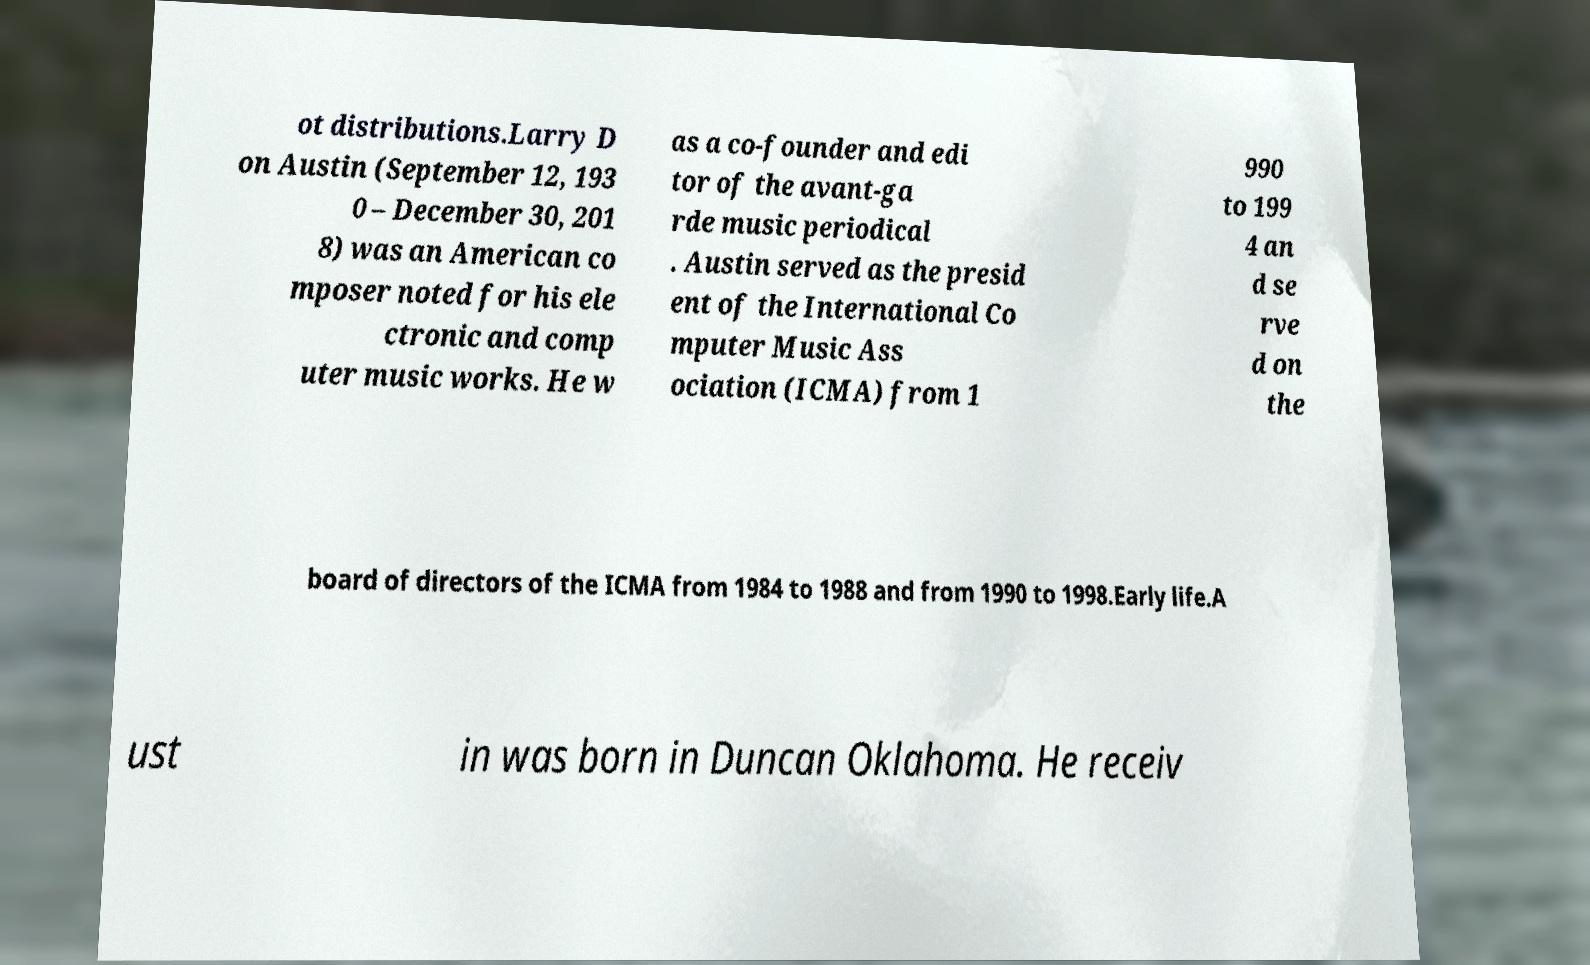For documentation purposes, I need the text within this image transcribed. Could you provide that? ot distributions.Larry D on Austin (September 12, 193 0 – December 30, 201 8) was an American co mposer noted for his ele ctronic and comp uter music works. He w as a co-founder and edi tor of the avant-ga rde music periodical . Austin served as the presid ent of the International Co mputer Music Ass ociation (ICMA) from 1 990 to 199 4 an d se rve d on the board of directors of the ICMA from 1984 to 1988 and from 1990 to 1998.Early life.A ust in was born in Duncan Oklahoma. He receiv 